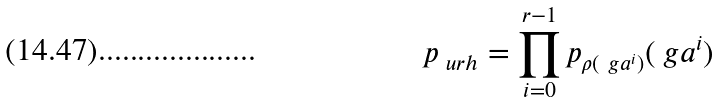<formula> <loc_0><loc_0><loc_500><loc_500>p _ { \ u r h } = \prod _ { i = 0 } ^ { r - 1 } p _ { \rho ( \ g a ^ { i } ) } ( \ g a ^ { i } )</formula> 